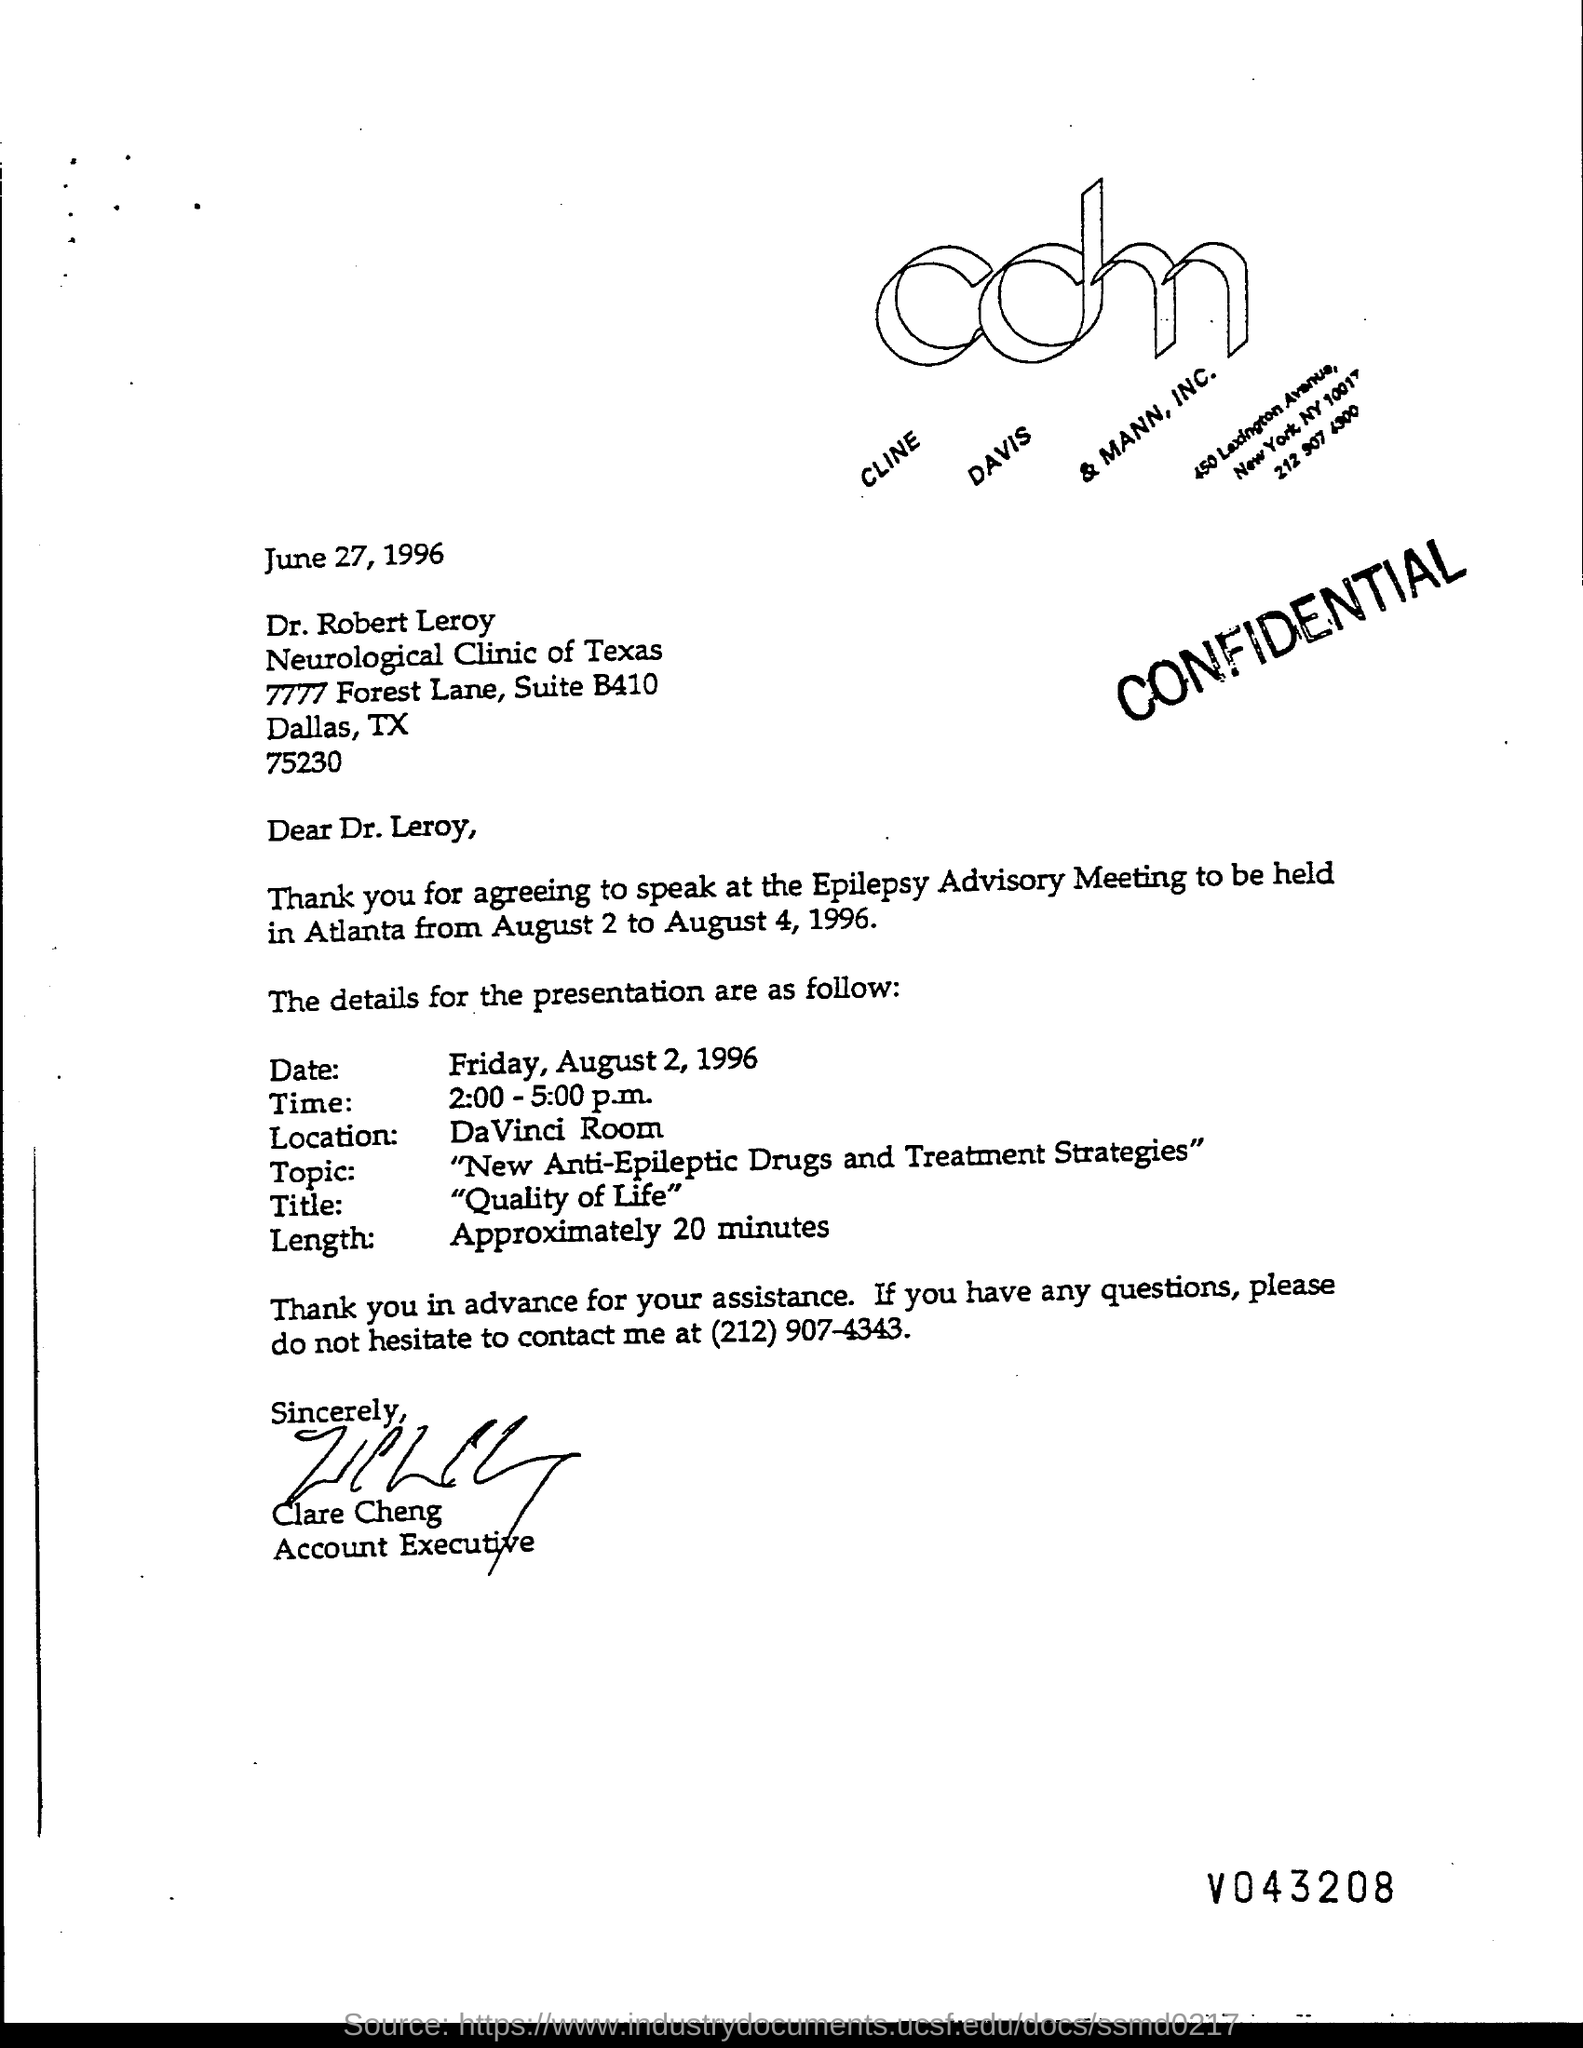Specify some key components in this picture. Clare Cheng's designation is Account Executive. The issued date of this letter is June 27, 1996. The title of the presentation given is "Quality of Life. The date of the scheduled presentation, as specified in the letter, is Friday, August 2, 1996. The sender of this letter is Clare Cheng. 